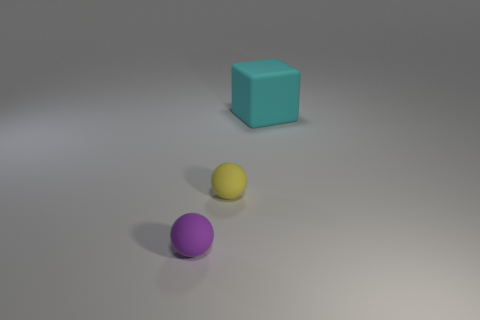There is a big rubber thing that is to the right of the ball that is behind the tiny purple object; are there any things in front of it?
Offer a terse response. Yes. What number of other things are there of the same shape as the large cyan rubber object?
Make the answer very short. 0. The thing that is both right of the tiny purple matte sphere and to the left of the large block has what shape?
Offer a terse response. Sphere. There is a small matte object on the right side of the small object that is on the left side of the tiny ball that is behind the small purple rubber thing; what color is it?
Your response must be concise. Yellow. Is the number of cubes that are on the left side of the small yellow object greater than the number of yellow spheres behind the purple matte ball?
Keep it short and to the point. No. How many other objects are there of the same size as the yellow matte sphere?
Provide a succinct answer. 1. There is a ball on the left side of the small sphere that is behind the tiny purple matte thing; what is it made of?
Provide a short and direct response. Rubber. Are there any big cyan rubber things on the left side of the matte block?
Your response must be concise. No. Are there more yellow rubber things that are behind the cube than large cyan things?
Your answer should be very brief. No. Are there any tiny things that have the same color as the cube?
Offer a very short reply. No. 